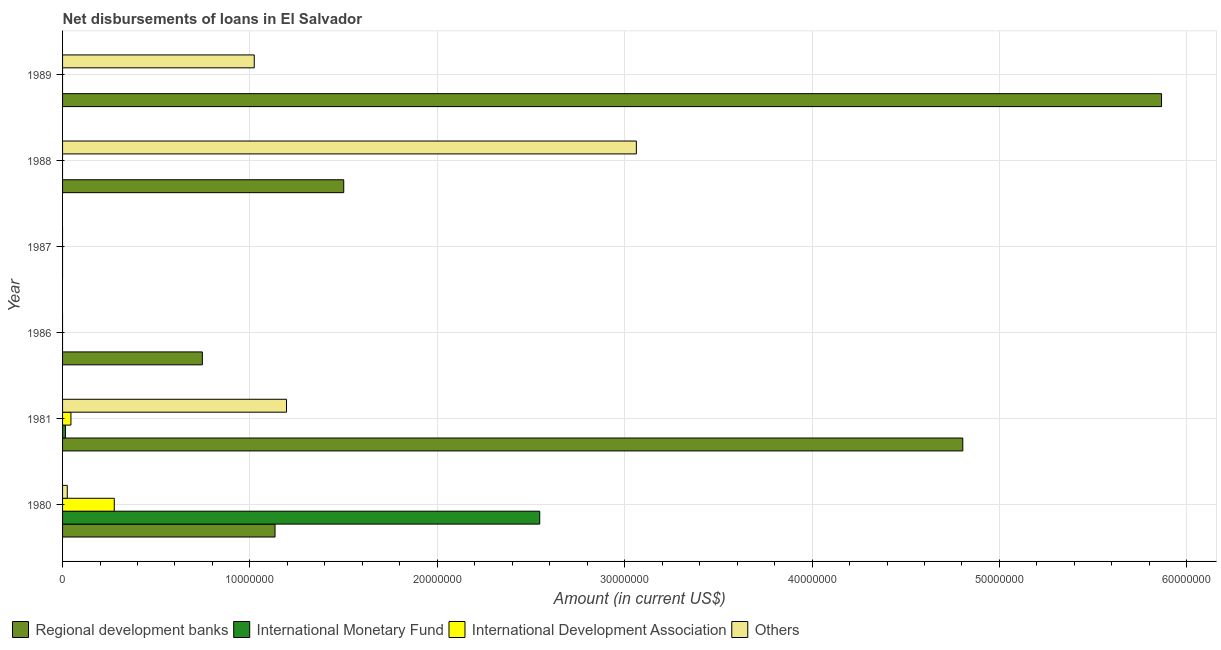How many different coloured bars are there?
Provide a short and direct response. 4. Are the number of bars on each tick of the Y-axis equal?
Keep it short and to the point. No. In how many cases, is the number of bars for a given year not equal to the number of legend labels?
Provide a short and direct response. 4. What is the amount of loan disimbursed by other organisations in 1989?
Ensure brevity in your answer.  1.02e+07. Across all years, what is the maximum amount of loan disimbursed by international monetary fund?
Provide a short and direct response. 2.55e+07. Across all years, what is the minimum amount of loan disimbursed by international development association?
Your response must be concise. 0. In which year was the amount of loan disimbursed by other organisations maximum?
Keep it short and to the point. 1988. What is the total amount of loan disimbursed by international monetary fund in the graph?
Your answer should be very brief. 2.56e+07. What is the difference between the amount of loan disimbursed by international development association in 1980 and that in 1981?
Provide a short and direct response. 2.31e+06. What is the difference between the amount of loan disimbursed by international development association in 1988 and the amount of loan disimbursed by other organisations in 1989?
Your answer should be compact. -1.02e+07. What is the average amount of loan disimbursed by other organisations per year?
Ensure brevity in your answer.  8.84e+06. In the year 1988, what is the difference between the amount of loan disimbursed by regional development banks and amount of loan disimbursed by other organisations?
Keep it short and to the point. -1.56e+07. What is the ratio of the amount of loan disimbursed by regional development banks in 1980 to that in 1981?
Provide a succinct answer. 0.24. What is the difference between the highest and the second highest amount of loan disimbursed by regional development banks?
Your answer should be compact. 1.06e+07. What is the difference between the highest and the lowest amount of loan disimbursed by international monetary fund?
Offer a terse response. 2.55e+07. Is it the case that in every year, the sum of the amount of loan disimbursed by international monetary fund and amount of loan disimbursed by regional development banks is greater than the sum of amount of loan disimbursed by other organisations and amount of loan disimbursed by international development association?
Offer a terse response. No. Is it the case that in every year, the sum of the amount of loan disimbursed by regional development banks and amount of loan disimbursed by international monetary fund is greater than the amount of loan disimbursed by international development association?
Offer a terse response. No. Are all the bars in the graph horizontal?
Offer a very short reply. Yes. How many years are there in the graph?
Give a very brief answer. 6. Are the values on the major ticks of X-axis written in scientific E-notation?
Give a very brief answer. No. Does the graph contain grids?
Your response must be concise. Yes. How many legend labels are there?
Keep it short and to the point. 4. What is the title of the graph?
Ensure brevity in your answer.  Net disbursements of loans in El Salvador. Does "Goods and services" appear as one of the legend labels in the graph?
Provide a succinct answer. No. What is the label or title of the X-axis?
Offer a terse response. Amount (in current US$). What is the Amount (in current US$) in Regional development banks in 1980?
Give a very brief answer. 1.13e+07. What is the Amount (in current US$) of International Monetary Fund in 1980?
Your answer should be compact. 2.55e+07. What is the Amount (in current US$) of International Development Association in 1980?
Offer a very short reply. 2.76e+06. What is the Amount (in current US$) of Others in 1980?
Your answer should be very brief. 2.52e+05. What is the Amount (in current US$) in Regional development banks in 1981?
Provide a succinct answer. 4.80e+07. What is the Amount (in current US$) of International Monetary Fund in 1981?
Provide a short and direct response. 1.56e+05. What is the Amount (in current US$) of International Development Association in 1981?
Ensure brevity in your answer.  4.47e+05. What is the Amount (in current US$) of Others in 1981?
Keep it short and to the point. 1.20e+07. What is the Amount (in current US$) in Regional development banks in 1986?
Your answer should be compact. 7.46e+06. What is the Amount (in current US$) in International Development Association in 1986?
Provide a succinct answer. 0. What is the Amount (in current US$) in Regional development banks in 1987?
Offer a terse response. 0. What is the Amount (in current US$) in Others in 1987?
Provide a short and direct response. 0. What is the Amount (in current US$) of Regional development banks in 1988?
Keep it short and to the point. 1.50e+07. What is the Amount (in current US$) of International Monetary Fund in 1988?
Your answer should be compact. 0. What is the Amount (in current US$) of International Development Association in 1988?
Make the answer very short. 0. What is the Amount (in current US$) of Others in 1988?
Your response must be concise. 3.06e+07. What is the Amount (in current US$) in Regional development banks in 1989?
Ensure brevity in your answer.  5.87e+07. What is the Amount (in current US$) in International Monetary Fund in 1989?
Offer a terse response. 0. What is the Amount (in current US$) of Others in 1989?
Offer a very short reply. 1.02e+07. Across all years, what is the maximum Amount (in current US$) in Regional development banks?
Your answer should be very brief. 5.87e+07. Across all years, what is the maximum Amount (in current US$) in International Monetary Fund?
Offer a very short reply. 2.55e+07. Across all years, what is the maximum Amount (in current US$) in International Development Association?
Your answer should be very brief. 2.76e+06. Across all years, what is the maximum Amount (in current US$) in Others?
Offer a terse response. 3.06e+07. Across all years, what is the minimum Amount (in current US$) in Regional development banks?
Make the answer very short. 0. Across all years, what is the minimum Amount (in current US$) in International Development Association?
Your response must be concise. 0. Across all years, what is the minimum Amount (in current US$) in Others?
Make the answer very short. 0. What is the total Amount (in current US$) in Regional development banks in the graph?
Your response must be concise. 1.41e+08. What is the total Amount (in current US$) of International Monetary Fund in the graph?
Offer a terse response. 2.56e+07. What is the total Amount (in current US$) in International Development Association in the graph?
Keep it short and to the point. 3.21e+06. What is the total Amount (in current US$) in Others in the graph?
Keep it short and to the point. 5.31e+07. What is the difference between the Amount (in current US$) of Regional development banks in 1980 and that in 1981?
Your answer should be very brief. -3.67e+07. What is the difference between the Amount (in current US$) in International Monetary Fund in 1980 and that in 1981?
Provide a short and direct response. 2.53e+07. What is the difference between the Amount (in current US$) in International Development Association in 1980 and that in 1981?
Provide a succinct answer. 2.31e+06. What is the difference between the Amount (in current US$) in Others in 1980 and that in 1981?
Offer a terse response. -1.17e+07. What is the difference between the Amount (in current US$) of Regional development banks in 1980 and that in 1986?
Provide a short and direct response. 3.88e+06. What is the difference between the Amount (in current US$) in Regional development banks in 1980 and that in 1988?
Provide a succinct answer. -3.67e+06. What is the difference between the Amount (in current US$) in Others in 1980 and that in 1988?
Provide a succinct answer. -3.04e+07. What is the difference between the Amount (in current US$) in Regional development banks in 1980 and that in 1989?
Your response must be concise. -4.73e+07. What is the difference between the Amount (in current US$) in Others in 1980 and that in 1989?
Your response must be concise. -9.98e+06. What is the difference between the Amount (in current US$) in Regional development banks in 1981 and that in 1986?
Provide a short and direct response. 4.06e+07. What is the difference between the Amount (in current US$) of Regional development banks in 1981 and that in 1988?
Your answer should be compact. 3.30e+07. What is the difference between the Amount (in current US$) in Others in 1981 and that in 1988?
Provide a succinct answer. -1.87e+07. What is the difference between the Amount (in current US$) in Regional development banks in 1981 and that in 1989?
Offer a terse response. -1.06e+07. What is the difference between the Amount (in current US$) in Others in 1981 and that in 1989?
Give a very brief answer. 1.72e+06. What is the difference between the Amount (in current US$) of Regional development banks in 1986 and that in 1988?
Offer a terse response. -7.54e+06. What is the difference between the Amount (in current US$) in Regional development banks in 1986 and that in 1989?
Provide a short and direct response. -5.12e+07. What is the difference between the Amount (in current US$) in Regional development banks in 1988 and that in 1989?
Your answer should be compact. -4.36e+07. What is the difference between the Amount (in current US$) of Others in 1988 and that in 1989?
Keep it short and to the point. 2.04e+07. What is the difference between the Amount (in current US$) in Regional development banks in 1980 and the Amount (in current US$) in International Monetary Fund in 1981?
Your response must be concise. 1.12e+07. What is the difference between the Amount (in current US$) of Regional development banks in 1980 and the Amount (in current US$) of International Development Association in 1981?
Your answer should be compact. 1.09e+07. What is the difference between the Amount (in current US$) of Regional development banks in 1980 and the Amount (in current US$) of Others in 1981?
Provide a short and direct response. -6.13e+05. What is the difference between the Amount (in current US$) in International Monetary Fund in 1980 and the Amount (in current US$) in International Development Association in 1981?
Provide a succinct answer. 2.50e+07. What is the difference between the Amount (in current US$) of International Monetary Fund in 1980 and the Amount (in current US$) of Others in 1981?
Provide a short and direct response. 1.35e+07. What is the difference between the Amount (in current US$) in International Development Association in 1980 and the Amount (in current US$) in Others in 1981?
Your answer should be very brief. -9.19e+06. What is the difference between the Amount (in current US$) of Regional development banks in 1980 and the Amount (in current US$) of Others in 1988?
Give a very brief answer. -1.93e+07. What is the difference between the Amount (in current US$) of International Monetary Fund in 1980 and the Amount (in current US$) of Others in 1988?
Keep it short and to the point. -5.16e+06. What is the difference between the Amount (in current US$) in International Development Association in 1980 and the Amount (in current US$) in Others in 1988?
Provide a short and direct response. -2.79e+07. What is the difference between the Amount (in current US$) in Regional development banks in 1980 and the Amount (in current US$) in Others in 1989?
Your response must be concise. 1.11e+06. What is the difference between the Amount (in current US$) of International Monetary Fund in 1980 and the Amount (in current US$) of Others in 1989?
Your answer should be compact. 1.52e+07. What is the difference between the Amount (in current US$) of International Development Association in 1980 and the Amount (in current US$) of Others in 1989?
Offer a very short reply. -7.47e+06. What is the difference between the Amount (in current US$) of Regional development banks in 1981 and the Amount (in current US$) of Others in 1988?
Keep it short and to the point. 1.74e+07. What is the difference between the Amount (in current US$) in International Monetary Fund in 1981 and the Amount (in current US$) in Others in 1988?
Give a very brief answer. -3.05e+07. What is the difference between the Amount (in current US$) in International Development Association in 1981 and the Amount (in current US$) in Others in 1988?
Offer a very short reply. -3.02e+07. What is the difference between the Amount (in current US$) of Regional development banks in 1981 and the Amount (in current US$) of Others in 1989?
Keep it short and to the point. 3.78e+07. What is the difference between the Amount (in current US$) in International Monetary Fund in 1981 and the Amount (in current US$) in Others in 1989?
Make the answer very short. -1.01e+07. What is the difference between the Amount (in current US$) of International Development Association in 1981 and the Amount (in current US$) of Others in 1989?
Your response must be concise. -9.78e+06. What is the difference between the Amount (in current US$) in Regional development banks in 1986 and the Amount (in current US$) in Others in 1988?
Make the answer very short. -2.32e+07. What is the difference between the Amount (in current US$) of Regional development banks in 1986 and the Amount (in current US$) of Others in 1989?
Ensure brevity in your answer.  -2.77e+06. What is the difference between the Amount (in current US$) in Regional development banks in 1988 and the Amount (in current US$) in Others in 1989?
Make the answer very short. 4.78e+06. What is the average Amount (in current US$) of Regional development banks per year?
Your answer should be compact. 2.34e+07. What is the average Amount (in current US$) in International Monetary Fund per year?
Your answer should be very brief. 4.27e+06. What is the average Amount (in current US$) in International Development Association per year?
Make the answer very short. 5.34e+05. What is the average Amount (in current US$) in Others per year?
Provide a succinct answer. 8.84e+06. In the year 1980, what is the difference between the Amount (in current US$) of Regional development banks and Amount (in current US$) of International Monetary Fund?
Offer a terse response. -1.41e+07. In the year 1980, what is the difference between the Amount (in current US$) in Regional development banks and Amount (in current US$) in International Development Association?
Provide a short and direct response. 8.58e+06. In the year 1980, what is the difference between the Amount (in current US$) in Regional development banks and Amount (in current US$) in Others?
Give a very brief answer. 1.11e+07. In the year 1980, what is the difference between the Amount (in current US$) in International Monetary Fund and Amount (in current US$) in International Development Association?
Offer a very short reply. 2.27e+07. In the year 1980, what is the difference between the Amount (in current US$) of International Monetary Fund and Amount (in current US$) of Others?
Provide a short and direct response. 2.52e+07. In the year 1980, what is the difference between the Amount (in current US$) in International Development Association and Amount (in current US$) in Others?
Your response must be concise. 2.51e+06. In the year 1981, what is the difference between the Amount (in current US$) in Regional development banks and Amount (in current US$) in International Monetary Fund?
Provide a short and direct response. 4.79e+07. In the year 1981, what is the difference between the Amount (in current US$) of Regional development banks and Amount (in current US$) of International Development Association?
Provide a short and direct response. 4.76e+07. In the year 1981, what is the difference between the Amount (in current US$) in Regional development banks and Amount (in current US$) in Others?
Your answer should be compact. 3.61e+07. In the year 1981, what is the difference between the Amount (in current US$) of International Monetary Fund and Amount (in current US$) of International Development Association?
Ensure brevity in your answer.  -2.91e+05. In the year 1981, what is the difference between the Amount (in current US$) in International Monetary Fund and Amount (in current US$) in Others?
Keep it short and to the point. -1.18e+07. In the year 1981, what is the difference between the Amount (in current US$) of International Development Association and Amount (in current US$) of Others?
Ensure brevity in your answer.  -1.15e+07. In the year 1988, what is the difference between the Amount (in current US$) in Regional development banks and Amount (in current US$) in Others?
Your answer should be very brief. -1.56e+07. In the year 1989, what is the difference between the Amount (in current US$) in Regional development banks and Amount (in current US$) in Others?
Keep it short and to the point. 4.84e+07. What is the ratio of the Amount (in current US$) in Regional development banks in 1980 to that in 1981?
Provide a succinct answer. 0.24. What is the ratio of the Amount (in current US$) of International Monetary Fund in 1980 to that in 1981?
Offer a very short reply. 163.24. What is the ratio of the Amount (in current US$) in International Development Association in 1980 to that in 1981?
Offer a terse response. 6.17. What is the ratio of the Amount (in current US$) of Others in 1980 to that in 1981?
Provide a succinct answer. 0.02. What is the ratio of the Amount (in current US$) in Regional development banks in 1980 to that in 1986?
Make the answer very short. 1.52. What is the ratio of the Amount (in current US$) of Regional development banks in 1980 to that in 1988?
Provide a succinct answer. 0.76. What is the ratio of the Amount (in current US$) of Others in 1980 to that in 1988?
Ensure brevity in your answer.  0.01. What is the ratio of the Amount (in current US$) of Regional development banks in 1980 to that in 1989?
Ensure brevity in your answer.  0.19. What is the ratio of the Amount (in current US$) of Others in 1980 to that in 1989?
Ensure brevity in your answer.  0.02. What is the ratio of the Amount (in current US$) of Regional development banks in 1981 to that in 1986?
Give a very brief answer. 6.44. What is the ratio of the Amount (in current US$) in Regional development banks in 1981 to that in 1988?
Offer a very short reply. 3.2. What is the ratio of the Amount (in current US$) of Others in 1981 to that in 1988?
Provide a short and direct response. 0.39. What is the ratio of the Amount (in current US$) in Regional development banks in 1981 to that in 1989?
Ensure brevity in your answer.  0.82. What is the ratio of the Amount (in current US$) in Others in 1981 to that in 1989?
Offer a very short reply. 1.17. What is the ratio of the Amount (in current US$) of Regional development banks in 1986 to that in 1988?
Keep it short and to the point. 0.5. What is the ratio of the Amount (in current US$) in Regional development banks in 1986 to that in 1989?
Give a very brief answer. 0.13. What is the ratio of the Amount (in current US$) of Regional development banks in 1988 to that in 1989?
Your answer should be very brief. 0.26. What is the ratio of the Amount (in current US$) in Others in 1988 to that in 1989?
Provide a short and direct response. 2.99. What is the difference between the highest and the second highest Amount (in current US$) in Regional development banks?
Keep it short and to the point. 1.06e+07. What is the difference between the highest and the second highest Amount (in current US$) in Others?
Your response must be concise. 1.87e+07. What is the difference between the highest and the lowest Amount (in current US$) in Regional development banks?
Your response must be concise. 5.87e+07. What is the difference between the highest and the lowest Amount (in current US$) in International Monetary Fund?
Give a very brief answer. 2.55e+07. What is the difference between the highest and the lowest Amount (in current US$) in International Development Association?
Keep it short and to the point. 2.76e+06. What is the difference between the highest and the lowest Amount (in current US$) in Others?
Your response must be concise. 3.06e+07. 